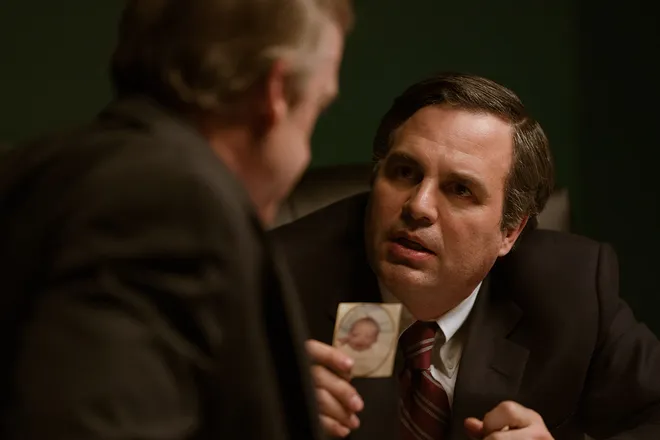What do the expressions and body language of the characters in this image suggest about their conversation? The expressions and body language depicted in this image suggest a moment of intense, earnest pleading or persuasion. The primary character, leaning forward with a focused and somewhat pleading expression, likely tries to convince or explain something crucial to the other. The second man, attentively listening while holding the photograph, appears concerned yet skeptical, adding a dynamic of challenge and urgency to their dialogue. 